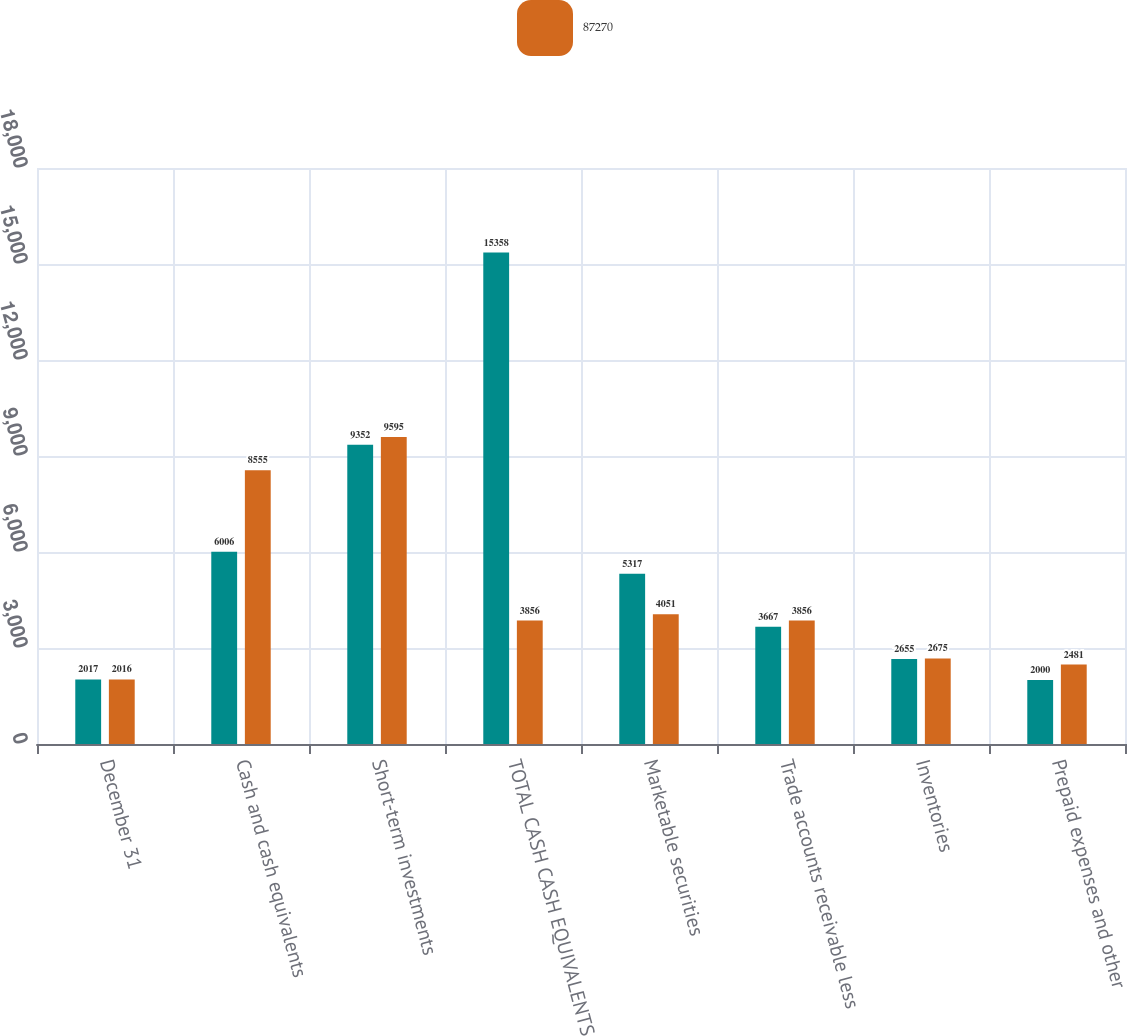<chart> <loc_0><loc_0><loc_500><loc_500><stacked_bar_chart><ecel><fcel>December 31<fcel>Cash and cash equivalents<fcel>Short-term investments<fcel>TOTAL CASH CASH EQUIVALENTS<fcel>Marketable securities<fcel>Trade accounts receivable less<fcel>Inventories<fcel>Prepaid expenses and other<nl><fcel>nan<fcel>2017<fcel>6006<fcel>9352<fcel>15358<fcel>5317<fcel>3667<fcel>2655<fcel>2000<nl><fcel>87270<fcel>2016<fcel>8555<fcel>9595<fcel>3856<fcel>4051<fcel>3856<fcel>2675<fcel>2481<nl></chart> 